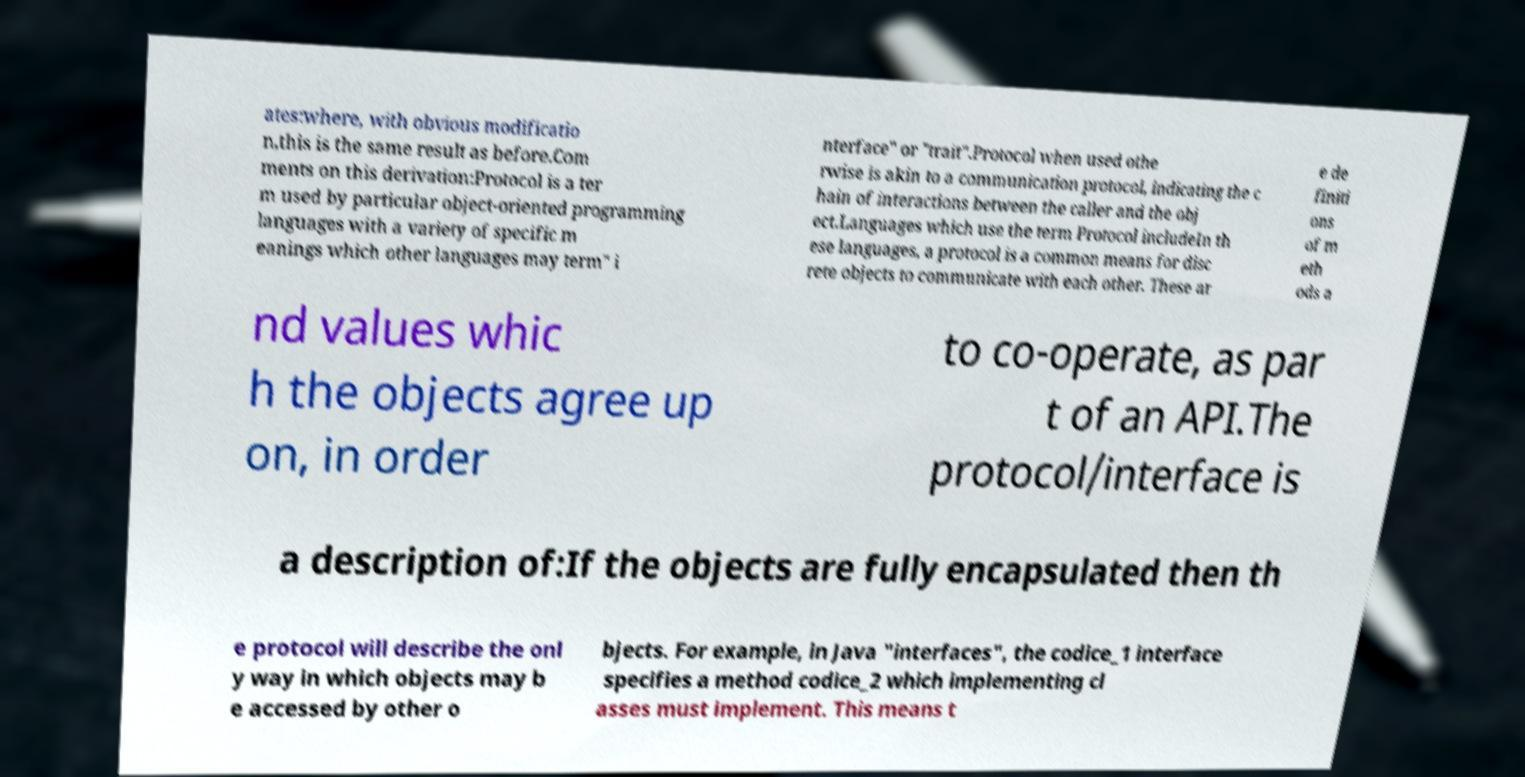There's text embedded in this image that I need extracted. Can you transcribe it verbatim? ates:where, with obvious modificatio n,this is the same result as before.Com ments on this derivation:Protocol is a ter m used by particular object-oriented programming languages with a variety of specific m eanings which other languages may term" i nterface" or "trait".Protocol when used othe rwise is akin to a communication protocol, indicating the c hain of interactions between the caller and the obj ect.Languages which use the term Protocol includeIn th ese languages, a protocol is a common means for disc rete objects to communicate with each other. These ar e de finiti ons of m eth ods a nd values whic h the objects agree up on, in order to co-operate, as par t of an API.The protocol/interface is a description of:If the objects are fully encapsulated then th e protocol will describe the onl y way in which objects may b e accessed by other o bjects. For example, in Java "interfaces", the codice_1 interface specifies a method codice_2 which implementing cl asses must implement. This means t 